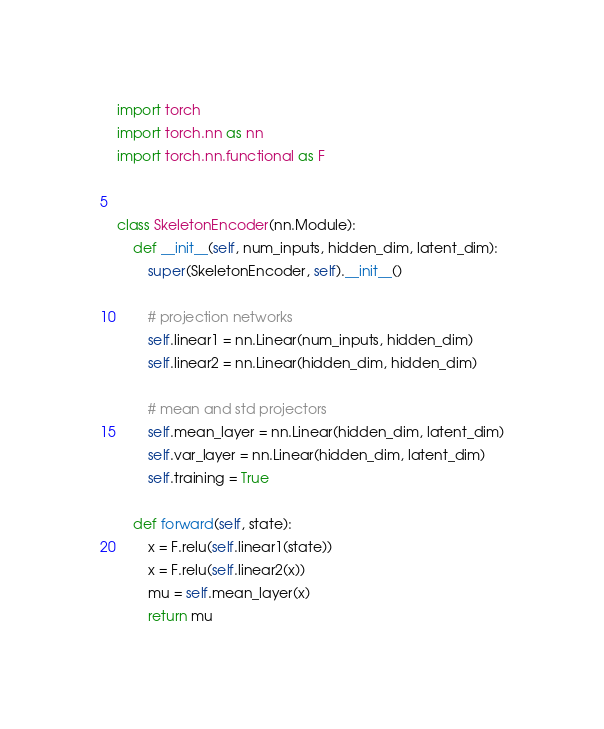<code> <loc_0><loc_0><loc_500><loc_500><_Python_>import torch
import torch.nn as nn
import torch.nn.functional as F


class SkeletonEncoder(nn.Module):
    def __init__(self, num_inputs, hidden_dim, latent_dim):
        super(SkeletonEncoder, self).__init__()

        # projection networks
        self.linear1 = nn.Linear(num_inputs, hidden_dim)
        self.linear2 = nn.Linear(hidden_dim, hidden_dim)

        # mean and std projectors
        self.mean_layer = nn.Linear(hidden_dim, latent_dim)
        self.var_layer = nn.Linear(hidden_dim, latent_dim)
        self.training = True

    def forward(self, state):
        x = F.relu(self.linear1(state))
        x = F.relu(self.linear2(x))
        mu = self.mean_layer(x)
        return mu</code> 